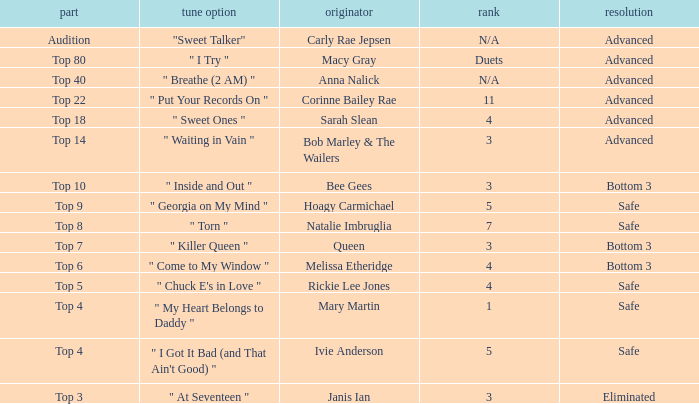What's the order number of the song originally performed by Rickie Lee Jones? 4.0. 